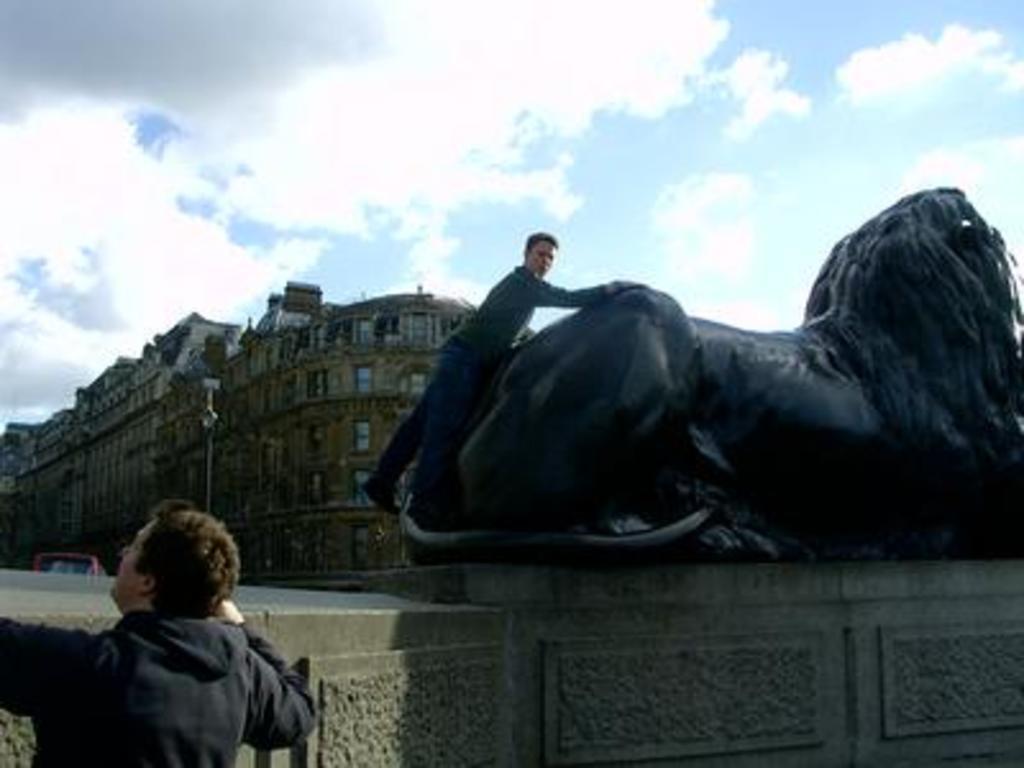Can you describe this image briefly? At the bottom left side of the image we can see one person standing and he is wearing a black color jacket. In the center of the image there is a solid structure. On the solid structure, we can see one man standing and one statue, which is in black color. In the background we can see the sky, clouds, buildings, windows, one pole, one vehicle and a few other objects. 